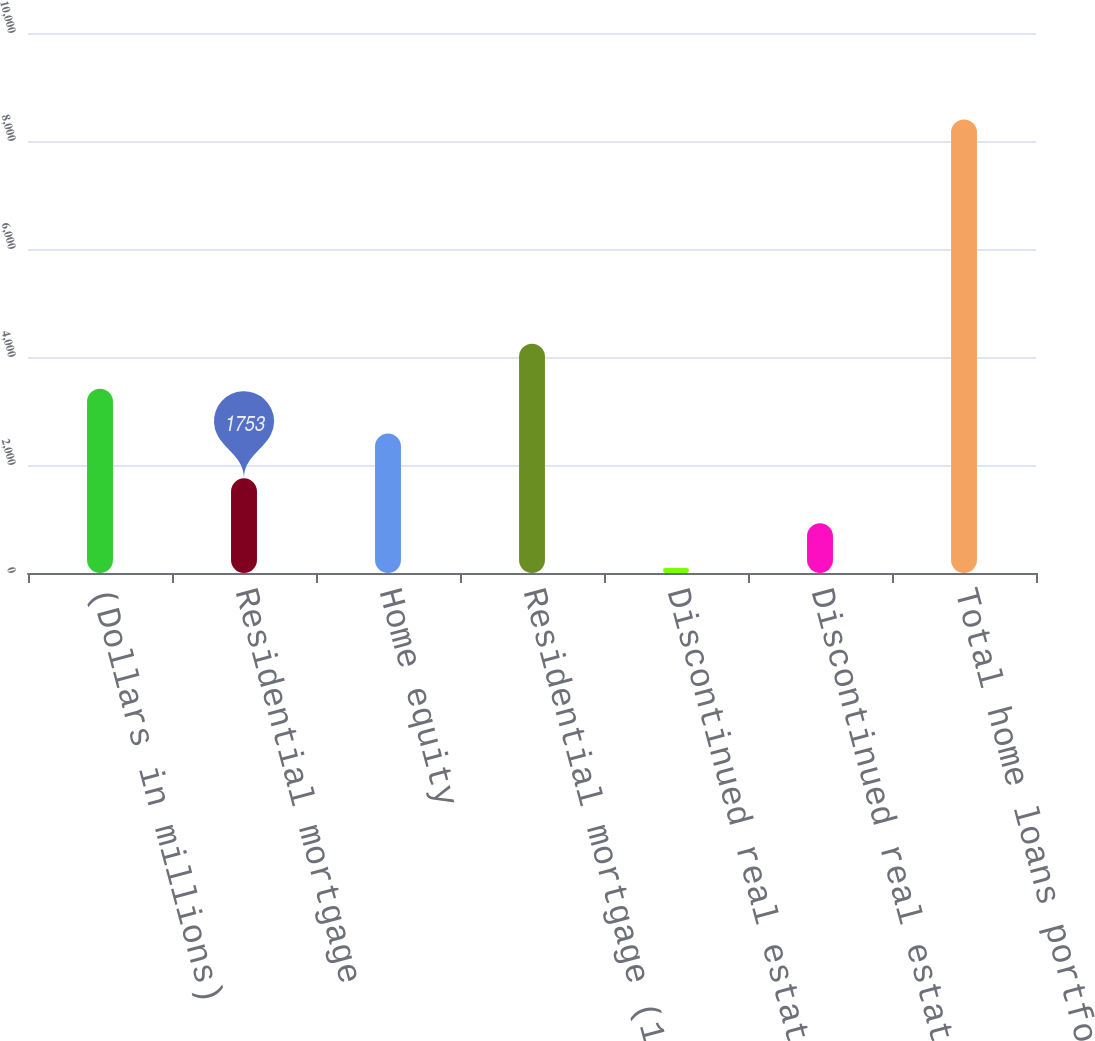Convert chart. <chart><loc_0><loc_0><loc_500><loc_500><bar_chart><fcel>(Dollars in millions)<fcel>Residential mortgage<fcel>Home equity<fcel>Residential mortgage (1)<fcel>Discontinued real estate (1)<fcel>Discontinued real estate<fcel>Total home loans portfolio<nl><fcel>3414<fcel>1753<fcel>2583.5<fcel>4244.5<fcel>92<fcel>922.5<fcel>8397<nl></chart> 